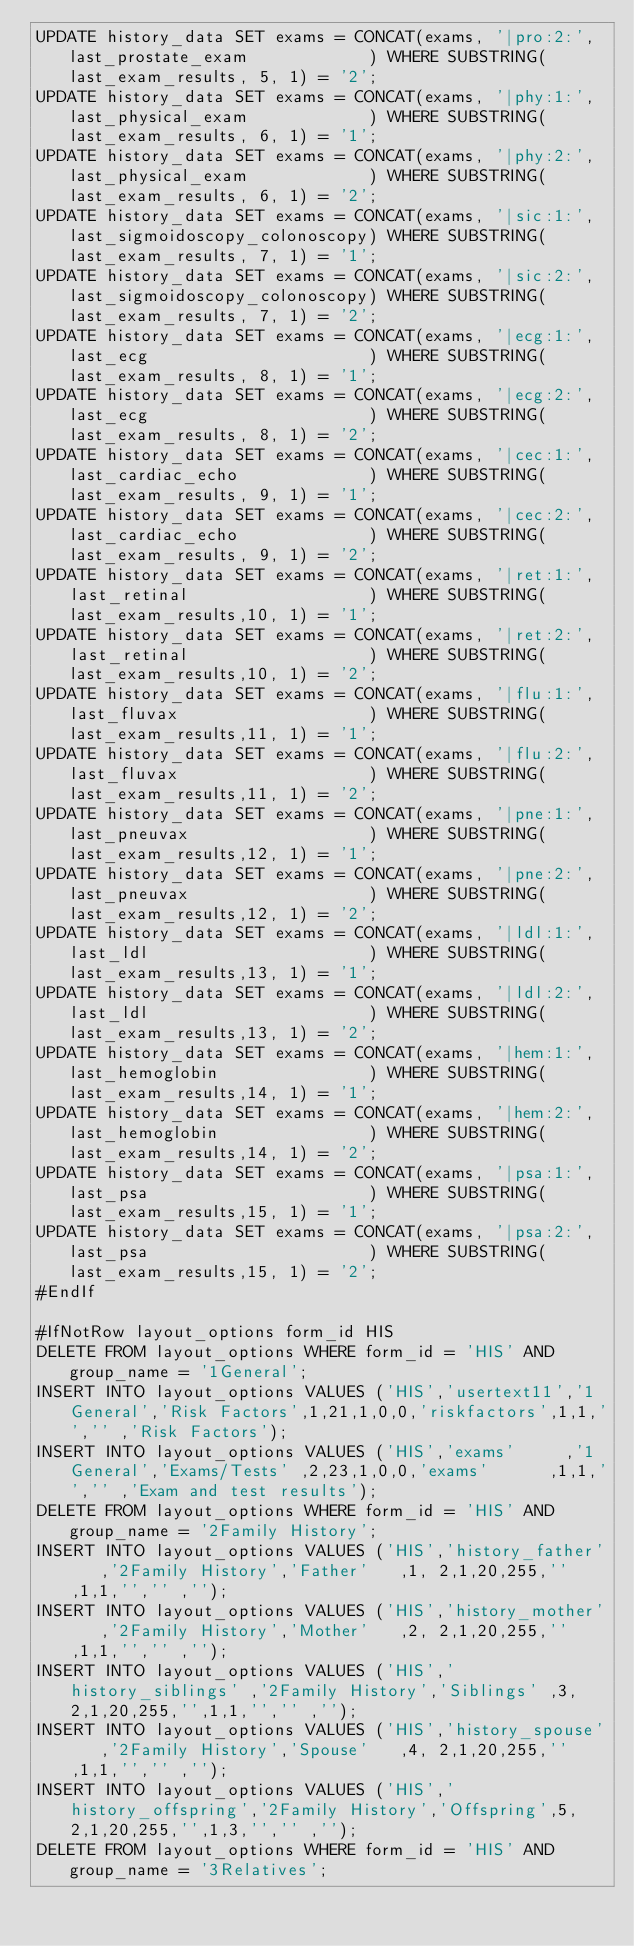Convert code to text. <code><loc_0><loc_0><loc_500><loc_500><_SQL_>UPDATE history_data SET exams = CONCAT(exams, '|pro:2:', last_prostate_exam            ) WHERE SUBSTRING(last_exam_results, 5, 1) = '2';
UPDATE history_data SET exams = CONCAT(exams, '|phy:1:', last_physical_exam            ) WHERE SUBSTRING(last_exam_results, 6, 1) = '1';
UPDATE history_data SET exams = CONCAT(exams, '|phy:2:', last_physical_exam            ) WHERE SUBSTRING(last_exam_results, 6, 1) = '2';
UPDATE history_data SET exams = CONCAT(exams, '|sic:1:', last_sigmoidoscopy_colonoscopy) WHERE SUBSTRING(last_exam_results, 7, 1) = '1';
UPDATE history_data SET exams = CONCAT(exams, '|sic:2:', last_sigmoidoscopy_colonoscopy) WHERE SUBSTRING(last_exam_results, 7, 1) = '2';
UPDATE history_data SET exams = CONCAT(exams, '|ecg:1:', last_ecg                      ) WHERE SUBSTRING(last_exam_results, 8, 1) = '1';
UPDATE history_data SET exams = CONCAT(exams, '|ecg:2:', last_ecg                      ) WHERE SUBSTRING(last_exam_results, 8, 1) = '2';
UPDATE history_data SET exams = CONCAT(exams, '|cec:1:', last_cardiac_echo             ) WHERE SUBSTRING(last_exam_results, 9, 1) = '1';
UPDATE history_data SET exams = CONCAT(exams, '|cec:2:', last_cardiac_echo             ) WHERE SUBSTRING(last_exam_results, 9, 1) = '2';
UPDATE history_data SET exams = CONCAT(exams, '|ret:1:', last_retinal                  ) WHERE SUBSTRING(last_exam_results,10, 1) = '1';
UPDATE history_data SET exams = CONCAT(exams, '|ret:2:', last_retinal                  ) WHERE SUBSTRING(last_exam_results,10, 1) = '2';
UPDATE history_data SET exams = CONCAT(exams, '|flu:1:', last_fluvax                   ) WHERE SUBSTRING(last_exam_results,11, 1) = '1';
UPDATE history_data SET exams = CONCAT(exams, '|flu:2:', last_fluvax                   ) WHERE SUBSTRING(last_exam_results,11, 1) = '2';
UPDATE history_data SET exams = CONCAT(exams, '|pne:1:', last_pneuvax                  ) WHERE SUBSTRING(last_exam_results,12, 1) = '1';
UPDATE history_data SET exams = CONCAT(exams, '|pne:2:', last_pneuvax                  ) WHERE SUBSTRING(last_exam_results,12, 1) = '2';
UPDATE history_data SET exams = CONCAT(exams, '|ldl:1:', last_ldl                      ) WHERE SUBSTRING(last_exam_results,13, 1) = '1';
UPDATE history_data SET exams = CONCAT(exams, '|ldl:2:', last_ldl                      ) WHERE SUBSTRING(last_exam_results,13, 1) = '2';
UPDATE history_data SET exams = CONCAT(exams, '|hem:1:', last_hemoglobin               ) WHERE SUBSTRING(last_exam_results,14, 1) = '1';
UPDATE history_data SET exams = CONCAT(exams, '|hem:2:', last_hemoglobin               ) WHERE SUBSTRING(last_exam_results,14, 1) = '2';
UPDATE history_data SET exams = CONCAT(exams, '|psa:1:', last_psa                      ) WHERE SUBSTRING(last_exam_results,15, 1) = '1';
UPDATE history_data SET exams = CONCAT(exams, '|psa:2:', last_psa                      ) WHERE SUBSTRING(last_exam_results,15, 1) = '2';
#EndIf

#IfNotRow layout_options form_id HIS
DELETE FROM layout_options WHERE form_id = 'HIS' AND group_name = '1General';
INSERT INTO layout_options VALUES ('HIS','usertext11','1General','Risk Factors',1,21,1,0,0,'riskfactors',1,1,'','' ,'Risk Factors');
INSERT INTO layout_options VALUES ('HIS','exams'     ,'1General','Exams/Tests' ,2,23,1,0,0,'exams'      ,1,1,'','' ,'Exam and test results');
DELETE FROM layout_options WHERE form_id = 'HIS' AND group_name = '2Family History';
INSERT INTO layout_options VALUES ('HIS','history_father'   ,'2Family History','Father'   ,1, 2,1,20,255,'',1,1,'','' ,'');
INSERT INTO layout_options VALUES ('HIS','history_mother'   ,'2Family History','Mother'   ,2, 2,1,20,255,'',1,1,'','' ,'');
INSERT INTO layout_options VALUES ('HIS','history_siblings' ,'2Family History','Siblings' ,3, 2,1,20,255,'',1,1,'','' ,'');
INSERT INTO layout_options VALUES ('HIS','history_spouse'   ,'2Family History','Spouse'   ,4, 2,1,20,255,'',1,1,'','' ,'');
INSERT INTO layout_options VALUES ('HIS','history_offspring','2Family History','Offspring',5, 2,1,20,255,'',1,3,'','' ,'');
DELETE FROM layout_options WHERE form_id = 'HIS' AND group_name = '3Relatives';</code> 